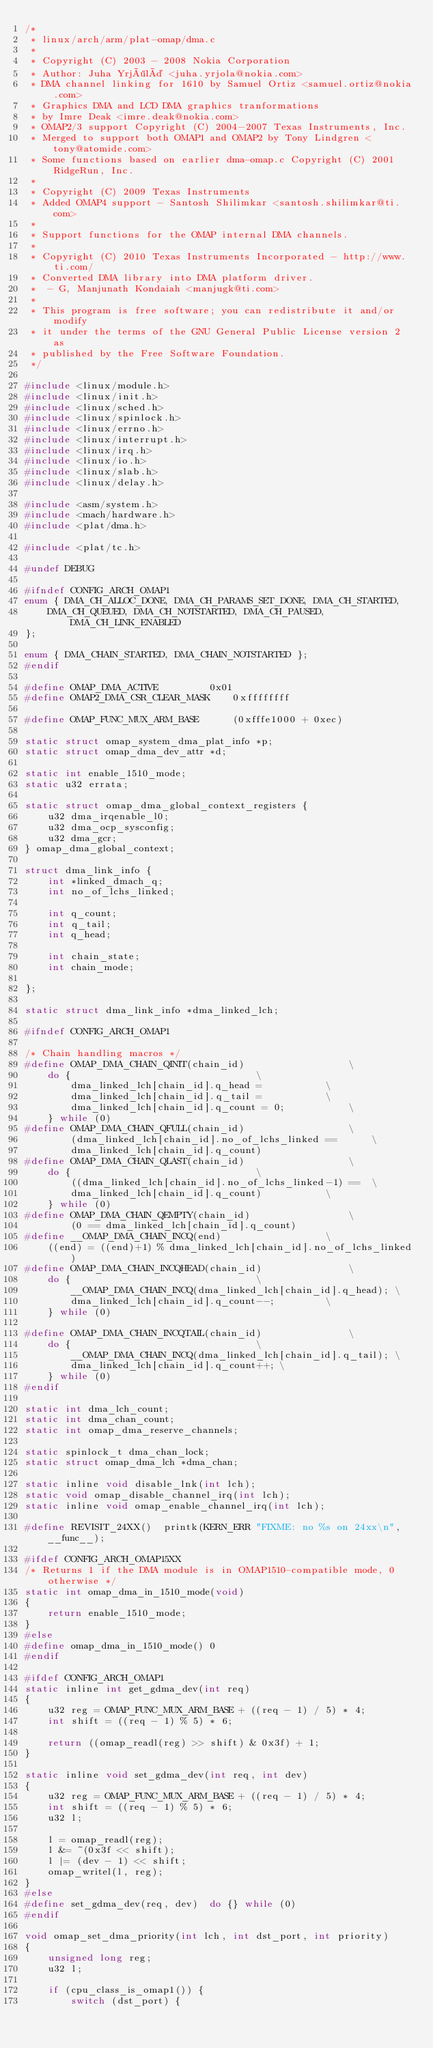<code> <loc_0><loc_0><loc_500><loc_500><_C_>/*
 * linux/arch/arm/plat-omap/dma.c
 *
 * Copyright (C) 2003 - 2008 Nokia Corporation
 * Author: Juha Yrjölä <juha.yrjola@nokia.com>
 * DMA channel linking for 1610 by Samuel Ortiz <samuel.ortiz@nokia.com>
 * Graphics DMA and LCD DMA graphics tranformations
 * by Imre Deak <imre.deak@nokia.com>
 * OMAP2/3 support Copyright (C) 2004-2007 Texas Instruments, Inc.
 * Merged to support both OMAP1 and OMAP2 by Tony Lindgren <tony@atomide.com>
 * Some functions based on earlier dma-omap.c Copyright (C) 2001 RidgeRun, Inc.
 *
 * Copyright (C) 2009 Texas Instruments
 * Added OMAP4 support - Santosh Shilimkar <santosh.shilimkar@ti.com>
 *
 * Support functions for the OMAP internal DMA channels.
 *
 * Copyright (C) 2010 Texas Instruments Incorporated - http://www.ti.com/
 * Converted DMA library into DMA platform driver.
 *	- G, Manjunath Kondaiah <manjugk@ti.com>
 *
 * This program is free software; you can redistribute it and/or modify
 * it under the terms of the GNU General Public License version 2 as
 * published by the Free Software Foundation.
 */

#include <linux/module.h>
#include <linux/init.h>
#include <linux/sched.h>
#include <linux/spinlock.h>
#include <linux/errno.h>
#include <linux/interrupt.h>
#include <linux/irq.h>
#include <linux/io.h>
#include <linux/slab.h>
#include <linux/delay.h>

#include <asm/system.h>
#include <mach/hardware.h>
#include <plat/dma.h>

#include <plat/tc.h>

#undef DEBUG

#ifndef CONFIG_ARCH_OMAP1
enum { DMA_CH_ALLOC_DONE, DMA_CH_PARAMS_SET_DONE, DMA_CH_STARTED,
	DMA_CH_QUEUED, DMA_CH_NOTSTARTED, DMA_CH_PAUSED, DMA_CH_LINK_ENABLED
};

enum { DMA_CHAIN_STARTED, DMA_CHAIN_NOTSTARTED };
#endif

#define OMAP_DMA_ACTIVE			0x01
#define OMAP2_DMA_CSR_CLEAR_MASK	0xffffffff

#define OMAP_FUNC_MUX_ARM_BASE		(0xfffe1000 + 0xec)

static struct omap_system_dma_plat_info *p;
static struct omap_dma_dev_attr *d;

static int enable_1510_mode;
static u32 errata;

static struct omap_dma_global_context_registers {
	u32 dma_irqenable_l0;
	u32 dma_ocp_sysconfig;
	u32 dma_gcr;
} omap_dma_global_context;

struct dma_link_info {
	int *linked_dmach_q;
	int no_of_lchs_linked;

	int q_count;
	int q_tail;
	int q_head;

	int chain_state;
	int chain_mode;

};

static struct dma_link_info *dma_linked_lch;

#ifndef CONFIG_ARCH_OMAP1

/* Chain handling macros */
#define OMAP_DMA_CHAIN_QINIT(chain_id)					\
	do {								\
		dma_linked_lch[chain_id].q_head =			\
		dma_linked_lch[chain_id].q_tail =			\
		dma_linked_lch[chain_id].q_count = 0;			\
	} while (0)
#define OMAP_DMA_CHAIN_QFULL(chain_id)					\
		(dma_linked_lch[chain_id].no_of_lchs_linked ==		\
		dma_linked_lch[chain_id].q_count)
#define OMAP_DMA_CHAIN_QLAST(chain_id)					\
	do {								\
		((dma_linked_lch[chain_id].no_of_lchs_linked-1) ==	\
		dma_linked_lch[chain_id].q_count)			\
	} while (0)
#define OMAP_DMA_CHAIN_QEMPTY(chain_id)					\
		(0 == dma_linked_lch[chain_id].q_count)
#define __OMAP_DMA_CHAIN_INCQ(end)					\
	((end) = ((end)+1) % dma_linked_lch[chain_id].no_of_lchs_linked)
#define OMAP_DMA_CHAIN_INCQHEAD(chain_id)				\
	do {								\
		__OMAP_DMA_CHAIN_INCQ(dma_linked_lch[chain_id].q_head);	\
		dma_linked_lch[chain_id].q_count--;			\
	} while (0)

#define OMAP_DMA_CHAIN_INCQTAIL(chain_id)				\
	do {								\
		__OMAP_DMA_CHAIN_INCQ(dma_linked_lch[chain_id].q_tail);	\
		dma_linked_lch[chain_id].q_count++; \
	} while (0)
#endif

static int dma_lch_count;
static int dma_chan_count;
static int omap_dma_reserve_channels;

static spinlock_t dma_chan_lock;
static struct omap_dma_lch *dma_chan;

static inline void disable_lnk(int lch);
static void omap_disable_channel_irq(int lch);
static inline void omap_enable_channel_irq(int lch);

#define REVISIT_24XX()	printk(KERN_ERR "FIXME: no %s on 24xx\n", __func__);

#ifdef CONFIG_ARCH_OMAP15XX
/* Returns 1 if the DMA module is in OMAP1510-compatible mode, 0 otherwise */
static int omap_dma_in_1510_mode(void)
{
	return enable_1510_mode;
}
#else
#define omap_dma_in_1510_mode()	0
#endif

#ifdef CONFIG_ARCH_OMAP1
static inline int get_gdma_dev(int req)
{
	u32 reg = OMAP_FUNC_MUX_ARM_BASE + ((req - 1) / 5) * 4;
	int shift = ((req - 1) % 5) * 6;

	return ((omap_readl(reg) >> shift) & 0x3f) + 1;
}

static inline void set_gdma_dev(int req, int dev)
{
	u32 reg = OMAP_FUNC_MUX_ARM_BASE + ((req - 1) / 5) * 4;
	int shift = ((req - 1) % 5) * 6;
	u32 l;

	l = omap_readl(reg);
	l &= ~(0x3f << shift);
	l |= (dev - 1) << shift;
	omap_writel(l, reg);
}
#else
#define set_gdma_dev(req, dev)	do {} while (0)
#endif

void omap_set_dma_priority(int lch, int dst_port, int priority)
{
	unsigned long reg;
	u32 l;

	if (cpu_class_is_omap1()) {
		switch (dst_port) {</code> 